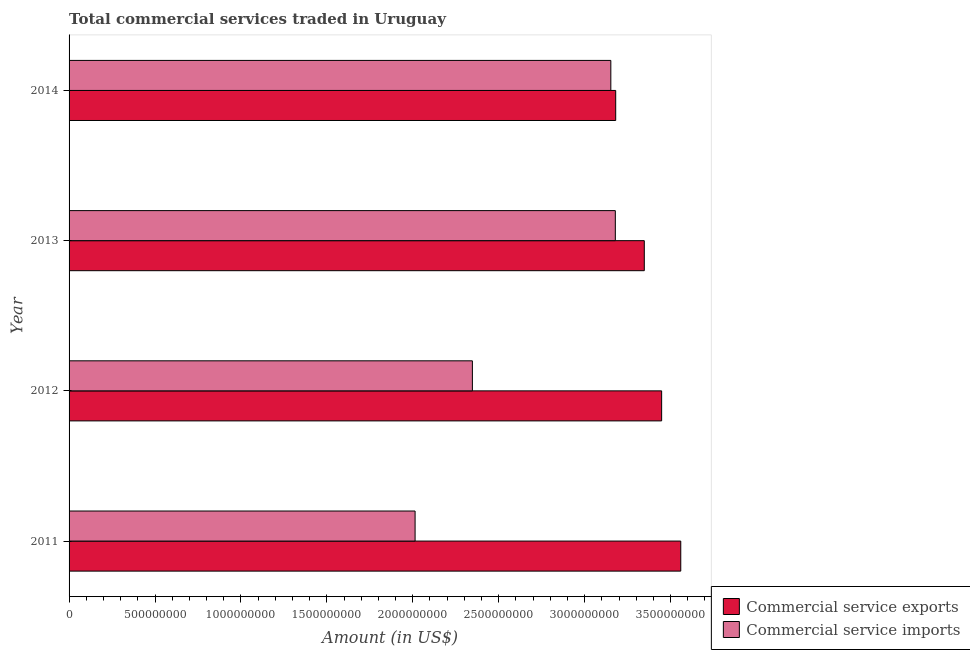How many groups of bars are there?
Ensure brevity in your answer.  4. Are the number of bars on each tick of the Y-axis equal?
Offer a terse response. Yes. How many bars are there on the 1st tick from the top?
Provide a short and direct response. 2. What is the amount of commercial service imports in 2011?
Ensure brevity in your answer.  2.01e+09. Across all years, what is the maximum amount of commercial service imports?
Your answer should be very brief. 3.18e+09. Across all years, what is the minimum amount of commercial service exports?
Keep it short and to the point. 3.18e+09. What is the total amount of commercial service imports in the graph?
Offer a terse response. 1.07e+1. What is the difference between the amount of commercial service exports in 2012 and that in 2013?
Ensure brevity in your answer.  1.01e+08. What is the difference between the amount of commercial service exports in 2013 and the amount of commercial service imports in 2011?
Provide a short and direct response. 1.33e+09. What is the average amount of commercial service exports per year?
Ensure brevity in your answer.  3.38e+09. In the year 2012, what is the difference between the amount of commercial service imports and amount of commercial service exports?
Offer a very short reply. -1.10e+09. In how many years, is the amount of commercial service exports greater than 3000000000 US$?
Ensure brevity in your answer.  4. What is the ratio of the amount of commercial service exports in 2012 to that in 2014?
Give a very brief answer. 1.08. Is the amount of commercial service exports in 2011 less than that in 2013?
Provide a short and direct response. No. Is the difference between the amount of commercial service exports in 2011 and 2012 greater than the difference between the amount of commercial service imports in 2011 and 2012?
Make the answer very short. Yes. What is the difference between the highest and the second highest amount of commercial service imports?
Your answer should be compact. 2.62e+07. What is the difference between the highest and the lowest amount of commercial service exports?
Provide a succinct answer. 3.79e+08. In how many years, is the amount of commercial service imports greater than the average amount of commercial service imports taken over all years?
Provide a succinct answer. 2. Is the sum of the amount of commercial service imports in 2011 and 2014 greater than the maximum amount of commercial service exports across all years?
Keep it short and to the point. Yes. What does the 2nd bar from the top in 2014 represents?
Your answer should be very brief. Commercial service exports. What does the 1st bar from the bottom in 2011 represents?
Your answer should be compact. Commercial service exports. How many bars are there?
Your answer should be very brief. 8. Are all the bars in the graph horizontal?
Ensure brevity in your answer.  Yes. How many years are there in the graph?
Ensure brevity in your answer.  4. Are the values on the major ticks of X-axis written in scientific E-notation?
Keep it short and to the point. No. Does the graph contain grids?
Your answer should be very brief. No. What is the title of the graph?
Ensure brevity in your answer.  Total commercial services traded in Uruguay. What is the Amount (in US$) in Commercial service exports in 2011?
Your response must be concise. 3.56e+09. What is the Amount (in US$) of Commercial service imports in 2011?
Your answer should be very brief. 2.01e+09. What is the Amount (in US$) in Commercial service exports in 2012?
Provide a succinct answer. 3.45e+09. What is the Amount (in US$) in Commercial service imports in 2012?
Provide a short and direct response. 2.35e+09. What is the Amount (in US$) in Commercial service exports in 2013?
Offer a terse response. 3.35e+09. What is the Amount (in US$) of Commercial service imports in 2013?
Make the answer very short. 3.18e+09. What is the Amount (in US$) of Commercial service exports in 2014?
Provide a short and direct response. 3.18e+09. What is the Amount (in US$) of Commercial service imports in 2014?
Provide a short and direct response. 3.15e+09. Across all years, what is the maximum Amount (in US$) in Commercial service exports?
Provide a succinct answer. 3.56e+09. Across all years, what is the maximum Amount (in US$) of Commercial service imports?
Provide a short and direct response. 3.18e+09. Across all years, what is the minimum Amount (in US$) in Commercial service exports?
Provide a short and direct response. 3.18e+09. Across all years, what is the minimum Amount (in US$) in Commercial service imports?
Offer a very short reply. 2.01e+09. What is the total Amount (in US$) of Commercial service exports in the graph?
Ensure brevity in your answer.  1.35e+1. What is the total Amount (in US$) in Commercial service imports in the graph?
Provide a short and direct response. 1.07e+1. What is the difference between the Amount (in US$) in Commercial service exports in 2011 and that in 2012?
Ensure brevity in your answer.  1.11e+08. What is the difference between the Amount (in US$) in Commercial service imports in 2011 and that in 2012?
Keep it short and to the point. -3.33e+08. What is the difference between the Amount (in US$) of Commercial service exports in 2011 and that in 2013?
Give a very brief answer. 2.12e+08. What is the difference between the Amount (in US$) of Commercial service imports in 2011 and that in 2013?
Ensure brevity in your answer.  -1.17e+09. What is the difference between the Amount (in US$) of Commercial service exports in 2011 and that in 2014?
Ensure brevity in your answer.  3.79e+08. What is the difference between the Amount (in US$) in Commercial service imports in 2011 and that in 2014?
Ensure brevity in your answer.  -1.14e+09. What is the difference between the Amount (in US$) of Commercial service exports in 2012 and that in 2013?
Offer a very short reply. 1.01e+08. What is the difference between the Amount (in US$) in Commercial service imports in 2012 and that in 2013?
Ensure brevity in your answer.  -8.32e+08. What is the difference between the Amount (in US$) of Commercial service exports in 2012 and that in 2014?
Keep it short and to the point. 2.67e+08. What is the difference between the Amount (in US$) in Commercial service imports in 2012 and that in 2014?
Your answer should be very brief. -8.05e+08. What is the difference between the Amount (in US$) in Commercial service exports in 2013 and that in 2014?
Your answer should be very brief. 1.66e+08. What is the difference between the Amount (in US$) of Commercial service imports in 2013 and that in 2014?
Your answer should be compact. 2.62e+07. What is the difference between the Amount (in US$) of Commercial service exports in 2011 and the Amount (in US$) of Commercial service imports in 2012?
Provide a short and direct response. 1.21e+09. What is the difference between the Amount (in US$) of Commercial service exports in 2011 and the Amount (in US$) of Commercial service imports in 2013?
Your response must be concise. 3.81e+08. What is the difference between the Amount (in US$) of Commercial service exports in 2011 and the Amount (in US$) of Commercial service imports in 2014?
Your answer should be very brief. 4.07e+08. What is the difference between the Amount (in US$) in Commercial service exports in 2012 and the Amount (in US$) in Commercial service imports in 2013?
Keep it short and to the point. 2.70e+08. What is the difference between the Amount (in US$) in Commercial service exports in 2012 and the Amount (in US$) in Commercial service imports in 2014?
Provide a short and direct response. 2.96e+08. What is the difference between the Amount (in US$) of Commercial service exports in 2013 and the Amount (in US$) of Commercial service imports in 2014?
Your answer should be compact. 1.95e+08. What is the average Amount (in US$) in Commercial service exports per year?
Your response must be concise. 3.38e+09. What is the average Amount (in US$) of Commercial service imports per year?
Ensure brevity in your answer.  2.67e+09. In the year 2011, what is the difference between the Amount (in US$) of Commercial service exports and Amount (in US$) of Commercial service imports?
Your answer should be compact. 1.55e+09. In the year 2012, what is the difference between the Amount (in US$) in Commercial service exports and Amount (in US$) in Commercial service imports?
Provide a succinct answer. 1.10e+09. In the year 2013, what is the difference between the Amount (in US$) in Commercial service exports and Amount (in US$) in Commercial service imports?
Offer a terse response. 1.69e+08. In the year 2014, what is the difference between the Amount (in US$) in Commercial service exports and Amount (in US$) in Commercial service imports?
Offer a very short reply. 2.84e+07. What is the ratio of the Amount (in US$) of Commercial service exports in 2011 to that in 2012?
Provide a succinct answer. 1.03. What is the ratio of the Amount (in US$) of Commercial service imports in 2011 to that in 2012?
Your response must be concise. 0.86. What is the ratio of the Amount (in US$) in Commercial service exports in 2011 to that in 2013?
Your answer should be compact. 1.06. What is the ratio of the Amount (in US$) in Commercial service imports in 2011 to that in 2013?
Your answer should be compact. 0.63. What is the ratio of the Amount (in US$) in Commercial service exports in 2011 to that in 2014?
Your answer should be very brief. 1.12. What is the ratio of the Amount (in US$) in Commercial service imports in 2011 to that in 2014?
Offer a terse response. 0.64. What is the ratio of the Amount (in US$) of Commercial service exports in 2012 to that in 2013?
Ensure brevity in your answer.  1.03. What is the ratio of the Amount (in US$) in Commercial service imports in 2012 to that in 2013?
Give a very brief answer. 0.74. What is the ratio of the Amount (in US$) in Commercial service exports in 2012 to that in 2014?
Offer a terse response. 1.08. What is the ratio of the Amount (in US$) of Commercial service imports in 2012 to that in 2014?
Your answer should be compact. 0.74. What is the ratio of the Amount (in US$) of Commercial service exports in 2013 to that in 2014?
Your answer should be very brief. 1.05. What is the ratio of the Amount (in US$) in Commercial service imports in 2013 to that in 2014?
Offer a terse response. 1.01. What is the difference between the highest and the second highest Amount (in US$) of Commercial service exports?
Provide a short and direct response. 1.11e+08. What is the difference between the highest and the second highest Amount (in US$) in Commercial service imports?
Offer a very short reply. 2.62e+07. What is the difference between the highest and the lowest Amount (in US$) of Commercial service exports?
Offer a very short reply. 3.79e+08. What is the difference between the highest and the lowest Amount (in US$) of Commercial service imports?
Your answer should be very brief. 1.17e+09. 